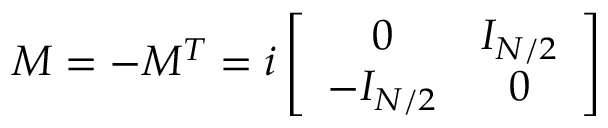<formula> <loc_0><loc_0><loc_500><loc_500>M = - M ^ { T } = i \left [ \begin{array} { c c } { 0 } & { { I _ { N / 2 } } } \\ { { - I _ { N / 2 } } } & { 0 } \end{array} \right ]</formula> 